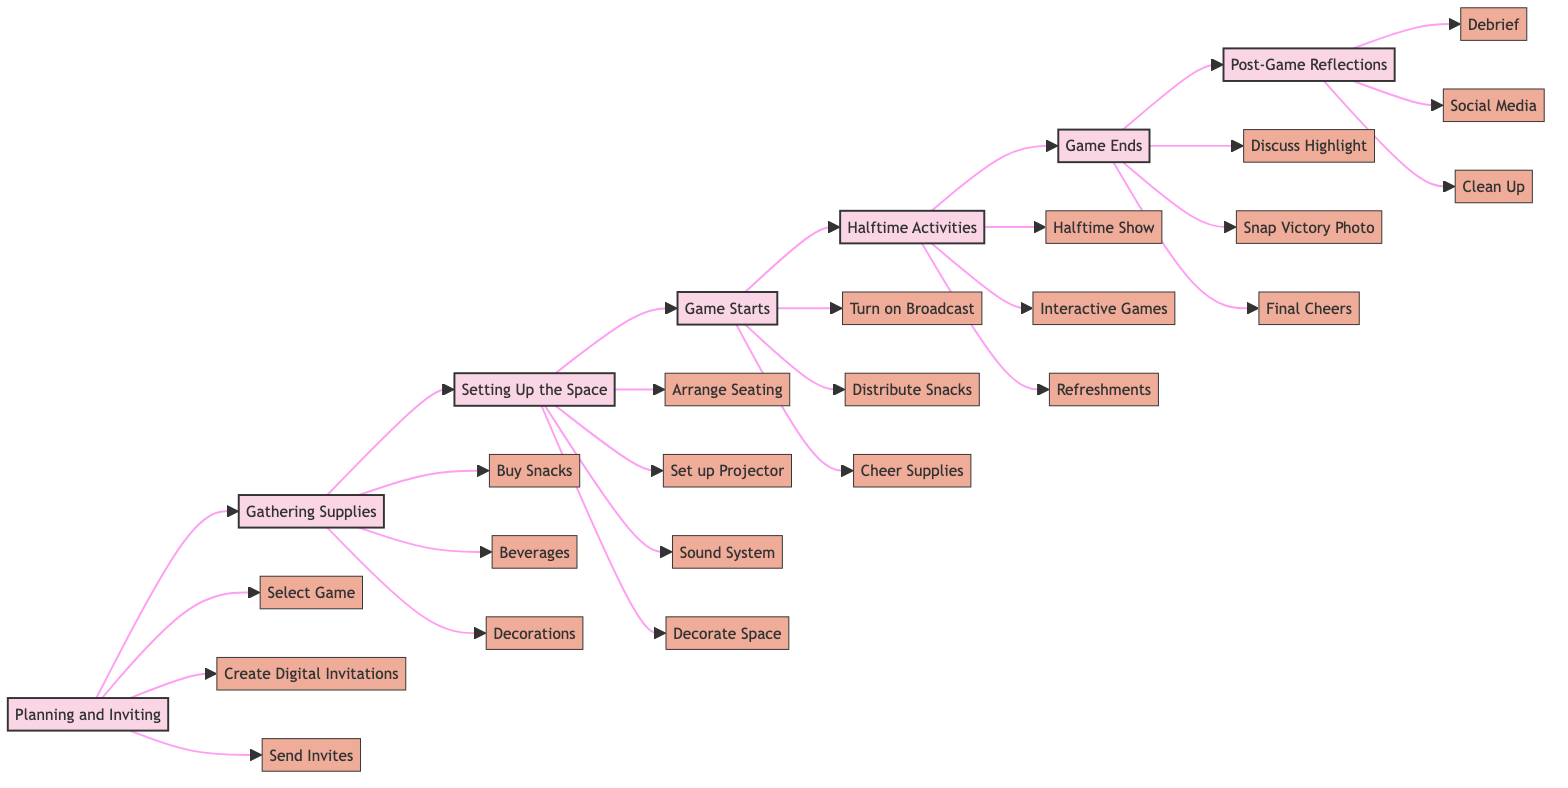What is the first stage of the watch party evolution? The first stage is labeled as "Planning and Inviting" in the diagram.
Answer: Planning and Inviting How many main stages are there in the game day watch party flowchart? Counting through the diagram, there are seven main stages labeled, which include Planning and Inviting, Gathering Supplies, Setting Up the Space, Game Starts, Halftime Activities, Game Ends, and Post-Game Reflections.
Answer: Seven What activity is highlighted in the "Halftime Activities" stage? The "Halftime Activities" stage includes three specific activities: Halftime Show, Interactive Games, and Refreshments, which indicates various ways to engage guests during halftime.
Answer: Halftime Show What supplies are distributed at the "Game Starts" stage? In the "Game Starts" stage, three supplies are distributed: Snacks, Broadcast, and Cheer Supplies, showing that the focus is on enhancing viewer experience right from the start.
Answer: Snacks Within "Gathering Supplies," which beverage is mentioned? The diagram specifies that "Craft Beer" is one of the beverages listed in the "Gathering Supplies" stage, along with others.
Answer: Craft Beer What follows the "Game Starts" stage in the flowchart? Following the "Game Starts" stage, the next stage is indicated as "Halftime Activities," establishing a clear sequence in the diagram.
Answer: Halftime Activities How many activities are listed in the "Post-Game Reflections"? The diagram identifies three activities in the "Post-Game Reflections" phase, showcasing different ways to process the game experience afterward.
Answer: Three What type of interactions are included in the "Halftime Activities"? "Interactive Games" such as Sports Trivia using Kahoot are included in the "Halftime Activities" stage, suggesting an engaging entertainment option for guests.
Answer: Interactive Games What is the last stage mentioned in the flowchart? The last stage in the flowchart is titled "Post-Game Reflections," marking the conclusion of the watch party planning and execution.
Answer: Post-Game Reflections 